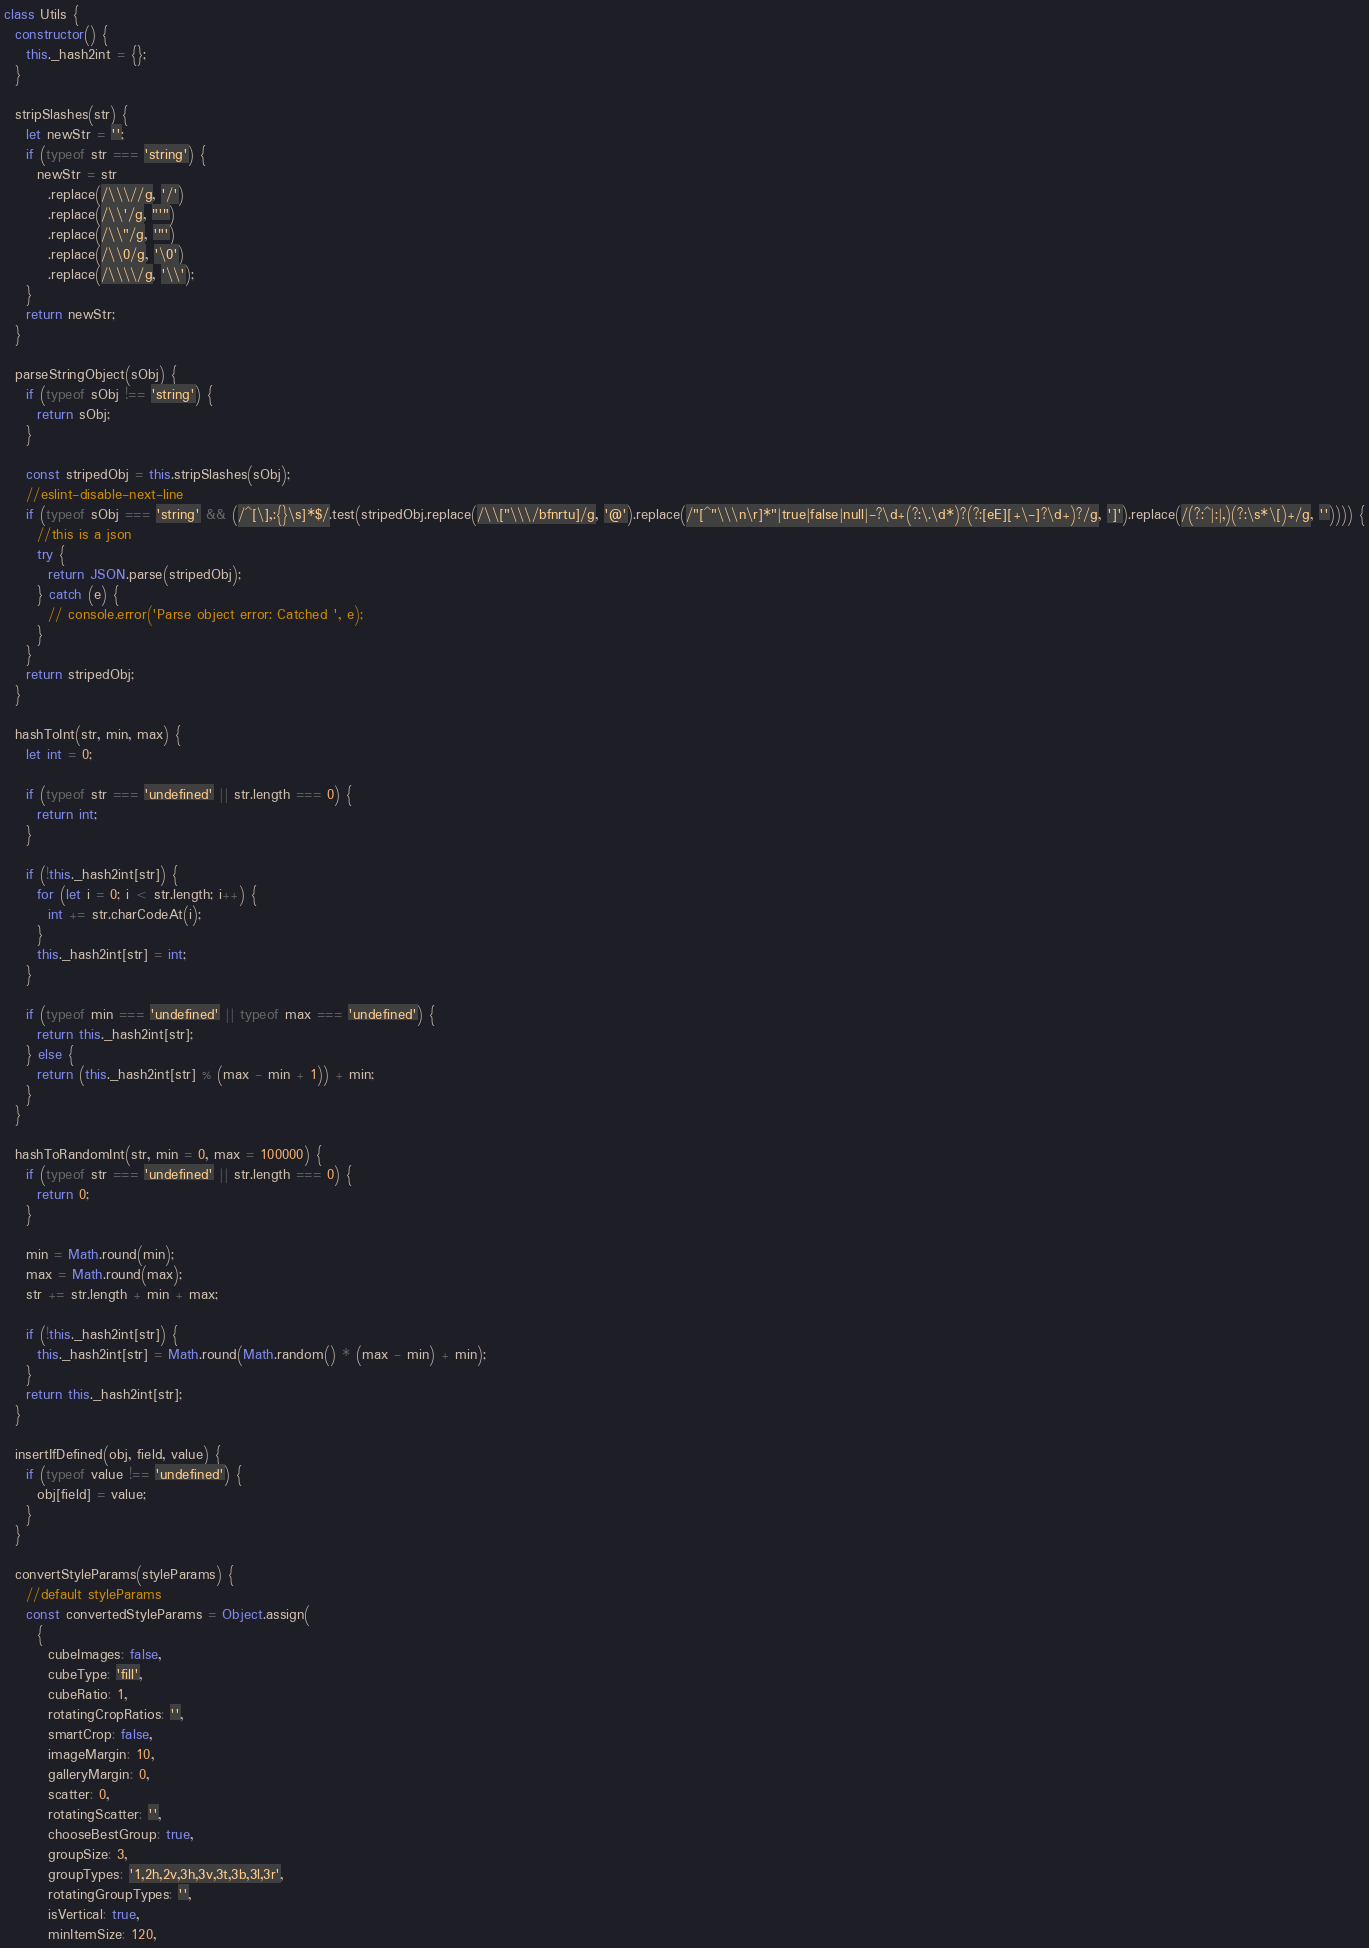Convert code to text. <code><loc_0><loc_0><loc_500><loc_500><_JavaScript_>class Utils {
  constructor() {
    this._hash2int = {};
  }

  stripSlashes(str) {
    let newStr = '';
    if (typeof str === 'string') {
      newStr = str
        .replace(/\\\//g, '/')
        .replace(/\\'/g, "'")
        .replace(/\\"/g, '"')
        .replace(/\\0/g, '\0')
        .replace(/\\\\/g, '\\');
    }
    return newStr;
  }

  parseStringObject(sObj) {
    if (typeof sObj !== 'string') {
      return sObj;
    }

    const stripedObj = this.stripSlashes(sObj);
    //eslint-disable-next-line
    if (typeof sObj === 'string' && (/^[\],:{}\s]*$/.test(stripedObj.replace(/\\["\\\/bfnrtu]/g, '@').replace(/"[^"\\\n\r]*"|true|false|null|-?\d+(?:\.\d*)?(?:[eE][+\-]?\d+)?/g, ']').replace(/(?:^|:|,)(?:\s*\[)+/g, '')))) {
      //this is a json
      try {
        return JSON.parse(stripedObj);
      } catch (e) {
        // console.error('Parse object error: Catched ', e);
      }
    }
    return stripedObj;
  }

  hashToInt(str, min, max) {
    let int = 0;

    if (typeof str === 'undefined' || str.length === 0) {
      return int;
    }

    if (!this._hash2int[str]) {
      for (let i = 0; i < str.length; i++) {
        int += str.charCodeAt(i);
      }
      this._hash2int[str] = int;
    }

    if (typeof min === 'undefined' || typeof max === 'undefined') {
      return this._hash2int[str];
    } else {
      return (this._hash2int[str] % (max - min + 1)) + min;
    }
  }

  hashToRandomInt(str, min = 0, max = 100000) {
    if (typeof str === 'undefined' || str.length === 0) {
      return 0;
    }

    min = Math.round(min);
    max = Math.round(max);
    str += str.length + min + max;

    if (!this._hash2int[str]) {
      this._hash2int[str] = Math.round(Math.random() * (max - min) + min);
    }
    return this._hash2int[str];
  }

  insertIfDefined(obj, field, value) {
    if (typeof value !== 'undefined') {
      obj[field] = value;
    }
  }

  convertStyleParams(styleParams) {
    //default styleParams
    const convertedStyleParams = Object.assign(
      {
        cubeImages: false,
        cubeType: 'fill',
        cubeRatio: 1,
        rotatingCropRatios: '',
        smartCrop: false,
        imageMargin: 10,
        galleryMargin: 0,
        scatter: 0,
        rotatingScatter: '',
        chooseBestGroup: true,
        groupSize: 3,
        groupTypes: '1,2h,2v,3h,3v,3t,3b,3l,3r',
        rotatingGroupTypes: '',
        isVertical: true,
        minItemSize: 120,</code> 